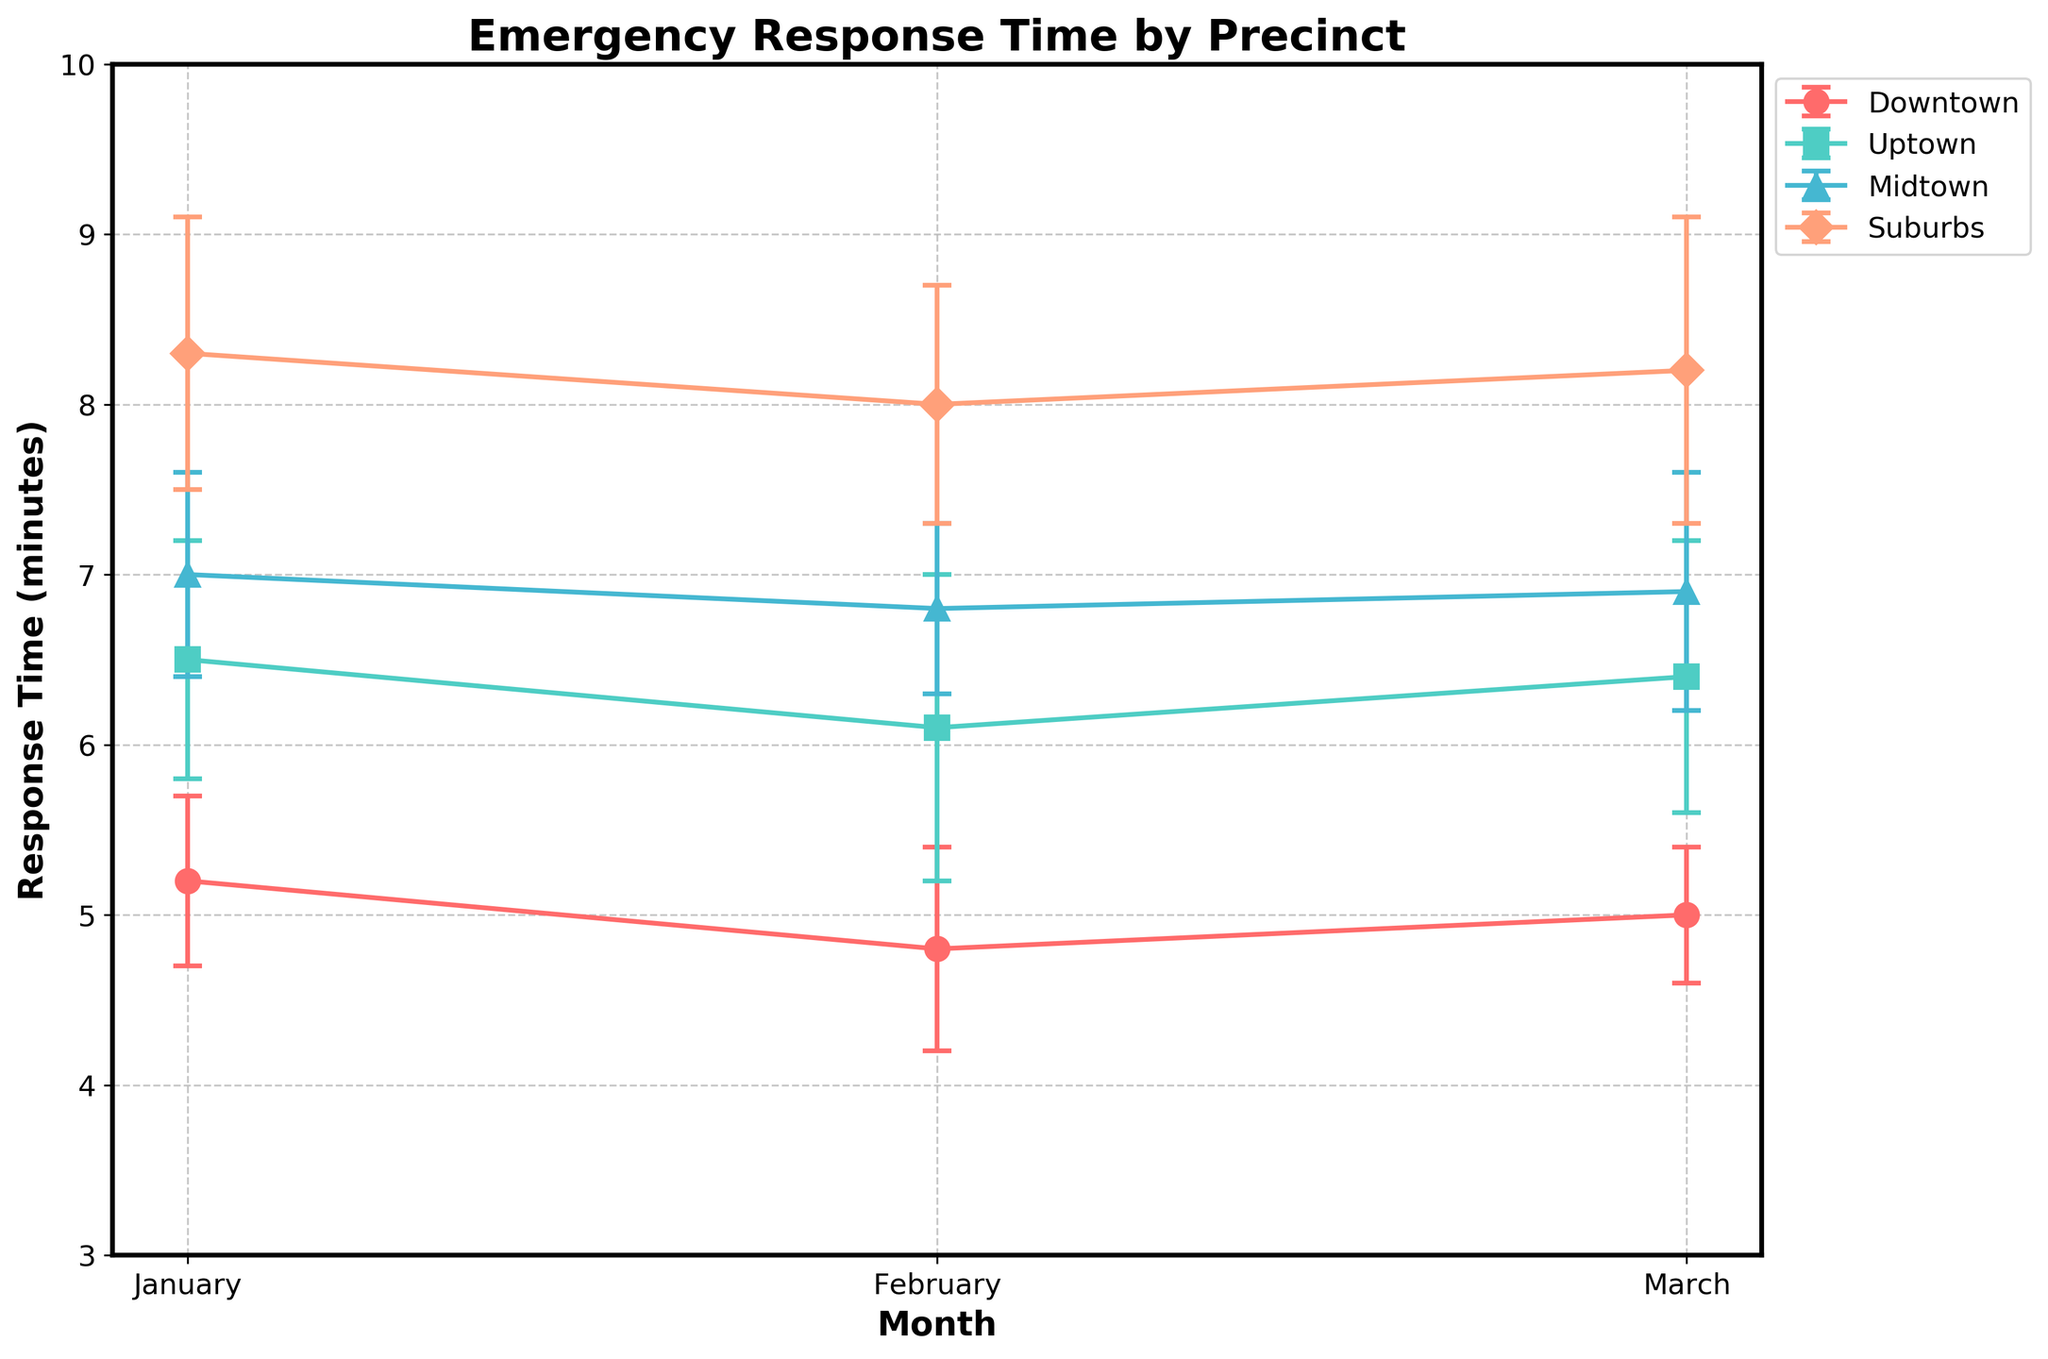Which precinct has the highest response time in January? Look at the error bars for January and identify the bar with the highest top endpoint. Downtown has 5.2±0.5, Uptown has 6.5±0.7, Midtown has 7.0±0.6, and Suburbs has 8.3±0.8. Suburbs has the highest upper endpoint.
Answer: Suburbs Which precinct showed the most improvement in response time from January to February? Compare the response times of each precinct from January to February. Calculate the difference for each: Downtown (5.2 - 4.8 = 0.4), Uptown (6.5 - 6.1 = 0.4), Midtown (7.0 - 6.8 = 0.2), Suburbs (8.3 - 8.0 = 0.3). Downtown and Uptown show the most improved response time with a 0.4 minutes decrease.
Answer: Downtown, Uptown In which month did Midtown have the lowest response time? Compare Midtown's response times over the three months. January is 7.0, February is 6.8, and March is 6.9. February has the lowest response time.
Answer: February What is the overall trend in response times for Uptown from January to March? Examine the response times of Uptown across the months. Uptown starts with 6.5 in January, decreases to 6.1 in February, and then slightly increases to 6.4 in March. Overall, the trend is a slight decrease.
Answer: Decreasing How does Suburbs' February response time compare to March? Look for Suburbs' response times in February and March and compare. February is 8.0±0.7, and March is 8.2±0.9. March is slightly higher.
Answer: March is higher What is the average response time for Downtown across the three months? Sum the response times for Downtown across the three months, then divide by the number of months. (5.2 + 4.8 + 5.0) / 3 = 15 / 3 = 5.0
Answer: 5.0 Which precinct has the smallest variability in response times from January to March? Compare the standard deviations of each precinct across the months. Downtown: average of 0.5, 0.6, 0.4 = 0.5; Uptown: average of 0.7, 0.9, 0.8 = 0.8; Midtown: average of 0.6, 0.5, 0.7 = 0.6; Suburbs: average of 0.8, 0.7, 0.9 = 0.8. Downtown has the smallest average variability.
Answer: Downtown Was there ever a month when Downtown had a higher response time than Uptown? Compare Downtown and Uptown response times for each month: January (Downtown 5.2, Uptown 6.5), February (Downtown 4.8, Uptown 6.1), March (Downtown 5.0, Uptown 6.4). In all months, Downtown has a lower response time than Uptown.
Answer: No If you had to choose one precinct with the most consistent response time across the months, which would it be? Consistency can be judged by comparing the standard deviations. Downtown: 0.5, 0.6, 0.4; Uptown: 0.7, 0.9, 0.8; Midtown: 0.6, 0.5, 0.7; Suburbs: 0.8, 0.7, 0.9. Downtown has the smallest and most consistent std. deviation.
Answer: Downtown 